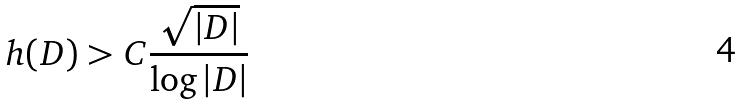<formula> <loc_0><loc_0><loc_500><loc_500>h ( D ) > C \frac { \sqrt { | D | } } { \log | D | }</formula> 